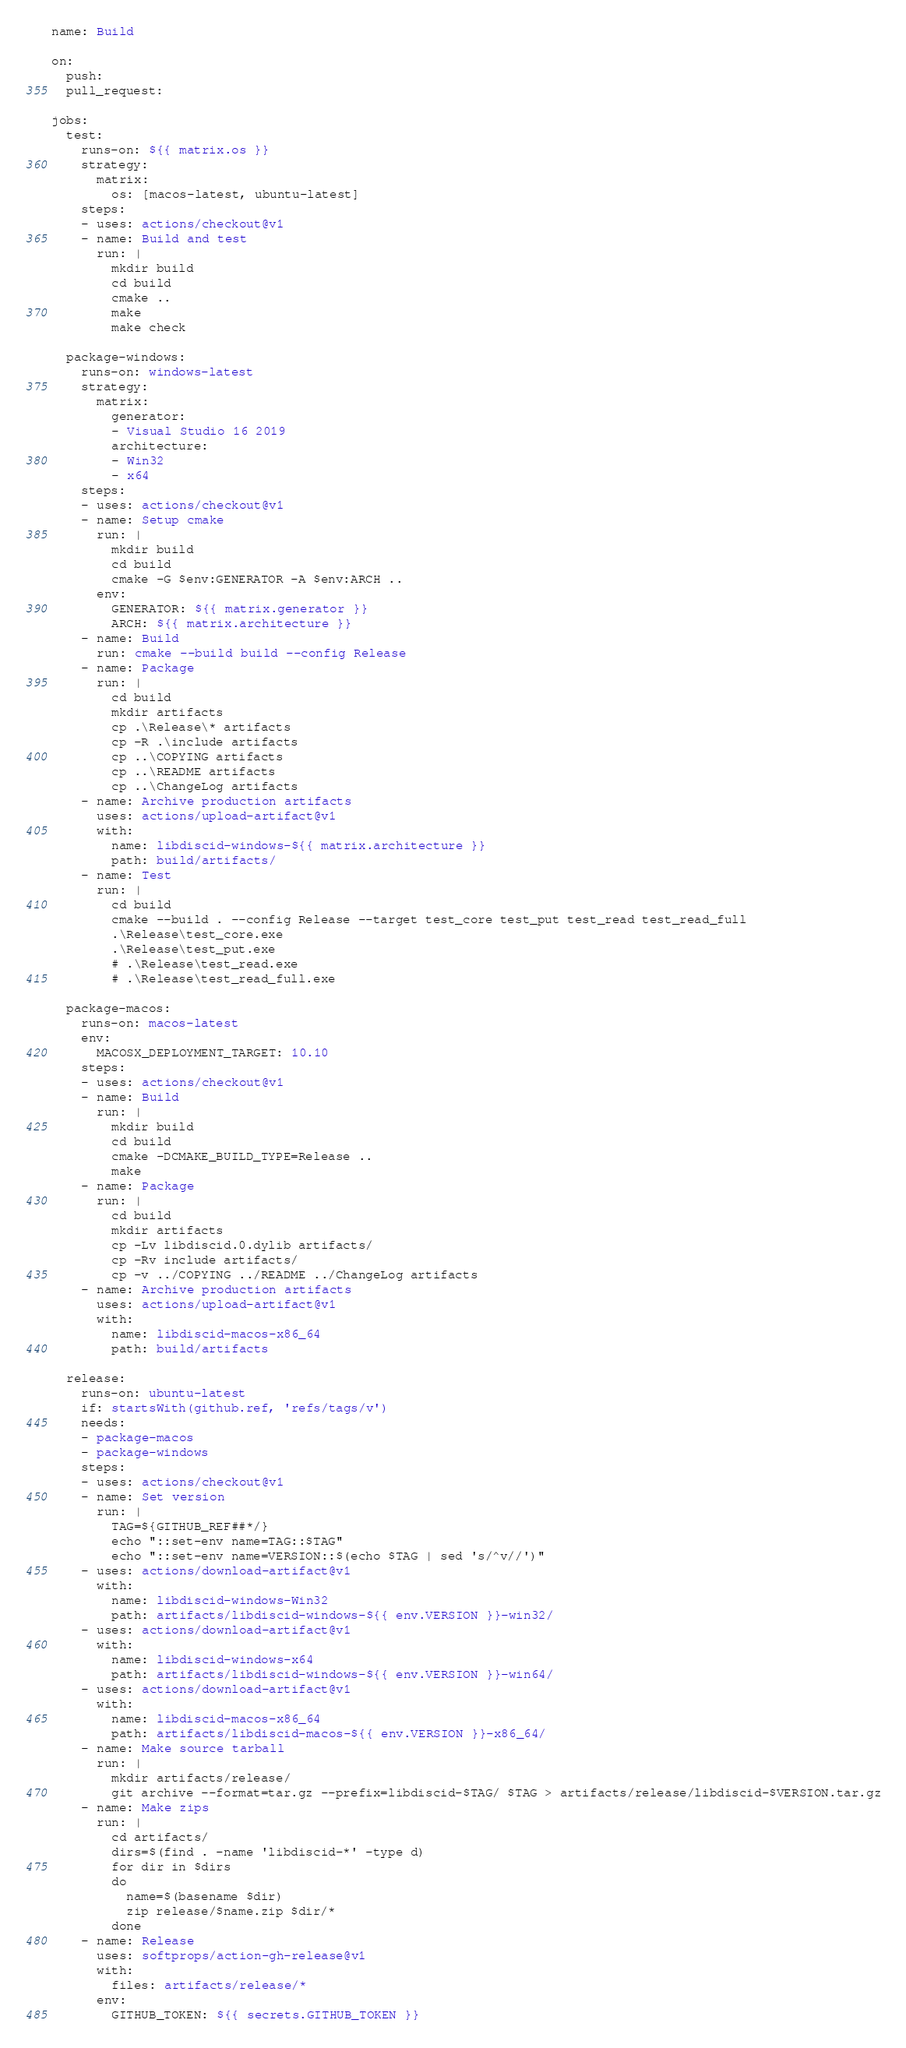<code> <loc_0><loc_0><loc_500><loc_500><_YAML_>name: Build

on:
  push:
  pull_request:

jobs:
  test:
    runs-on: ${{ matrix.os }}
    strategy:
      matrix:
        os: [macos-latest, ubuntu-latest]
    steps:
    - uses: actions/checkout@v1
    - name: Build and test
      run: |
        mkdir build
        cd build
        cmake ..
        make
        make check

  package-windows:
    runs-on: windows-latest
    strategy:
      matrix:
        generator:
        - Visual Studio 16 2019
        architecture:
        - Win32
        - x64
    steps:
    - uses: actions/checkout@v1
    - name: Setup cmake
      run: |
        mkdir build
        cd build
        cmake -G $env:GENERATOR -A $env:ARCH ..
      env:
        GENERATOR: ${{ matrix.generator }}
        ARCH: ${{ matrix.architecture }}
    - name: Build
      run: cmake --build build --config Release
    - name: Package
      run: |
        cd build
        mkdir artifacts
        cp .\Release\* artifacts
        cp -R .\include artifacts
        cp ..\COPYING artifacts
        cp ..\README artifacts
        cp ..\ChangeLog artifacts
    - name: Archive production artifacts
      uses: actions/upload-artifact@v1
      with:
        name: libdiscid-windows-${{ matrix.architecture }}
        path: build/artifacts/
    - name: Test
      run: |
        cd build
        cmake --build . --config Release --target test_core test_put test_read test_read_full
        .\Release\test_core.exe
        .\Release\test_put.exe
        # .\Release\test_read.exe
        # .\Release\test_read_full.exe

  package-macos:
    runs-on: macos-latest
    env:
      MACOSX_DEPLOYMENT_TARGET: 10.10
    steps:
    - uses: actions/checkout@v1
    - name: Build
      run: |
        mkdir build
        cd build
        cmake -DCMAKE_BUILD_TYPE=Release ..
        make
    - name: Package
      run: |
        cd build
        mkdir artifacts
        cp -Lv libdiscid.0.dylib artifacts/
        cp -Rv include artifacts/
        cp -v ../COPYING ../README ../ChangeLog artifacts
    - name: Archive production artifacts
      uses: actions/upload-artifact@v1
      with:
        name: libdiscid-macos-x86_64
        path: build/artifacts

  release:
    runs-on: ubuntu-latest
    if: startsWith(github.ref, 'refs/tags/v')
    needs:
    - package-macos
    - package-windows
    steps:
    - uses: actions/checkout@v1
    - name: Set version
      run: |
        TAG=${GITHUB_REF##*/}
        echo "::set-env name=TAG::$TAG"
        echo "::set-env name=VERSION::$(echo $TAG | sed 's/^v//')"
    - uses: actions/download-artifact@v1
      with:
        name: libdiscid-windows-Win32
        path: artifacts/libdiscid-windows-${{ env.VERSION }}-win32/
    - uses: actions/download-artifact@v1
      with:
        name: libdiscid-windows-x64
        path: artifacts/libdiscid-windows-${{ env.VERSION }}-win64/
    - uses: actions/download-artifact@v1
      with:
        name: libdiscid-macos-x86_64
        path: artifacts/libdiscid-macos-${{ env.VERSION }}-x86_64/
    - name: Make source tarball
      run: |
        mkdir artifacts/release/
        git archive --format=tar.gz --prefix=libdiscid-$TAG/ $TAG > artifacts/release/libdiscid-$VERSION.tar.gz
    - name: Make zips
      run: |
        cd artifacts/
        dirs=$(find . -name 'libdiscid-*' -type d)
        for dir in $dirs
        do
          name=$(basename $dir)
          zip release/$name.zip $dir/*
        done
    - name: Release
      uses: softprops/action-gh-release@v1
      with:
        files: artifacts/release/*
      env:
        GITHUB_TOKEN: ${{ secrets.GITHUB_TOKEN }}</code> 